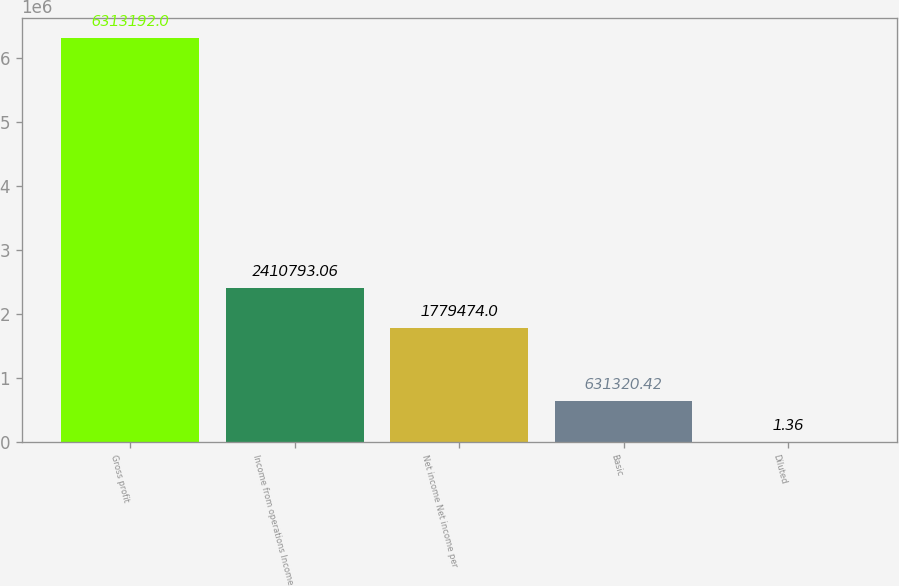Convert chart to OTSL. <chart><loc_0><loc_0><loc_500><loc_500><bar_chart><fcel>Gross profit<fcel>Income from operations Income<fcel>Net income Net income per<fcel>Basic<fcel>Diluted<nl><fcel>6.31319e+06<fcel>2.41079e+06<fcel>1.77947e+06<fcel>631320<fcel>1.36<nl></chart> 